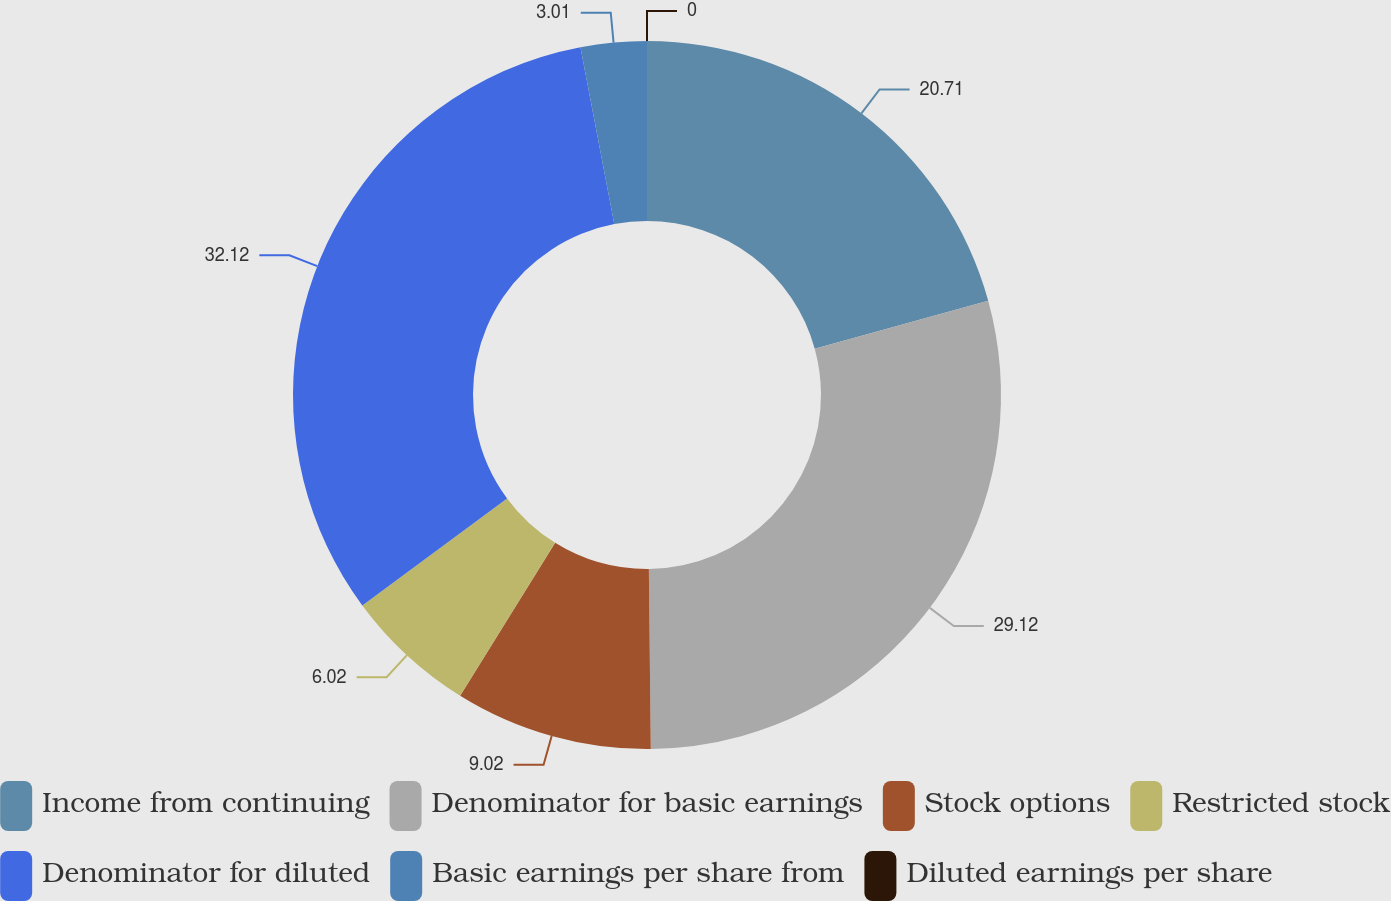Convert chart to OTSL. <chart><loc_0><loc_0><loc_500><loc_500><pie_chart><fcel>Income from continuing<fcel>Denominator for basic earnings<fcel>Stock options<fcel>Restricted stock<fcel>Denominator for diluted<fcel>Basic earnings per share from<fcel>Diluted earnings per share<nl><fcel>20.71%<fcel>29.12%<fcel>9.02%<fcel>6.02%<fcel>32.12%<fcel>3.01%<fcel>0.0%<nl></chart> 